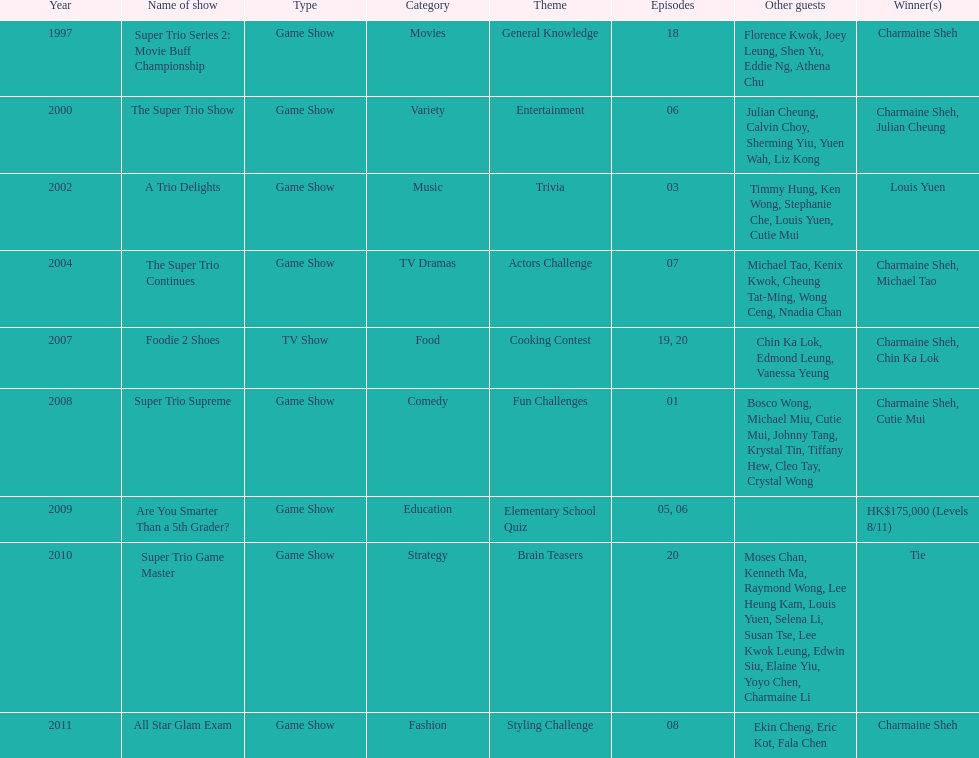Parse the table in full. {'header': ['Year', 'Name of show', 'Type', 'Category', 'Theme', 'Episodes', 'Other guests', 'Winner(s)'], 'rows': [['1997', 'Super Trio Series 2: Movie Buff Championship', 'Game Show', 'Movies', 'General Knowledge', '18', 'Florence Kwok, Joey Leung, Shen Yu, Eddie Ng, Athena Chu', 'Charmaine Sheh'], ['2000', 'The Super Trio Show', 'Game Show', 'Variety', 'Entertainment', '06', 'Julian Cheung, Calvin Choy, Sherming Yiu, Yuen Wah, Liz Kong', 'Charmaine Sheh, Julian Cheung'], ['2002', 'A Trio Delights', 'Game Show', 'Music', 'Trivia', '03', 'Timmy Hung, Ken Wong, Stephanie Che, Louis Yuen, Cutie Mui', 'Louis Yuen'], ['2004', 'The Super Trio Continues', 'Game Show', 'TV Dramas', 'Actors Challenge', '07', 'Michael Tao, Kenix Kwok, Cheung Tat-Ming, Wong Ceng, Nnadia Chan', 'Charmaine Sheh, Michael Tao'], ['2007', 'Foodie 2 Shoes', 'TV Show', 'Food', 'Cooking Contest', '19, 20', 'Chin Ka Lok, Edmond Leung, Vanessa Yeung', 'Charmaine Sheh, Chin Ka Lok'], ['2008', 'Super Trio Supreme', 'Game Show', 'Comedy', 'Fun Challenges', '01', 'Bosco Wong, Michael Miu, Cutie Mui, Johnny Tang, Krystal Tin, Tiffany Hew, Cleo Tay, Crystal Wong', 'Charmaine Sheh, Cutie Mui'], ['2009', 'Are You Smarter Than a 5th Grader?', 'Game Show', 'Education', 'Elementary School Quiz', '05, 06', '', 'HK$175,000 (Levels 8/11)'], ['2010', 'Super Trio Game Master', 'Game Show', 'Strategy', 'Brain Teasers', '20', 'Moses Chan, Kenneth Ma, Raymond Wong, Lee Heung Kam, Louis Yuen, Selena Li, Susan Tse, Lee Kwok Leung, Edwin Siu, Elaine Yiu, Yoyo Chen, Charmaine Li', 'Tie'], ['2011', 'All Star Glam Exam', 'Game Show', 'Fashion', 'Styling Challenge', '08', 'Ekin Cheng, Eric Kot, Fala Chen', 'Charmaine Sheh']]} What is the number of other guests in the 2002 show "a trio delights"? 5. 